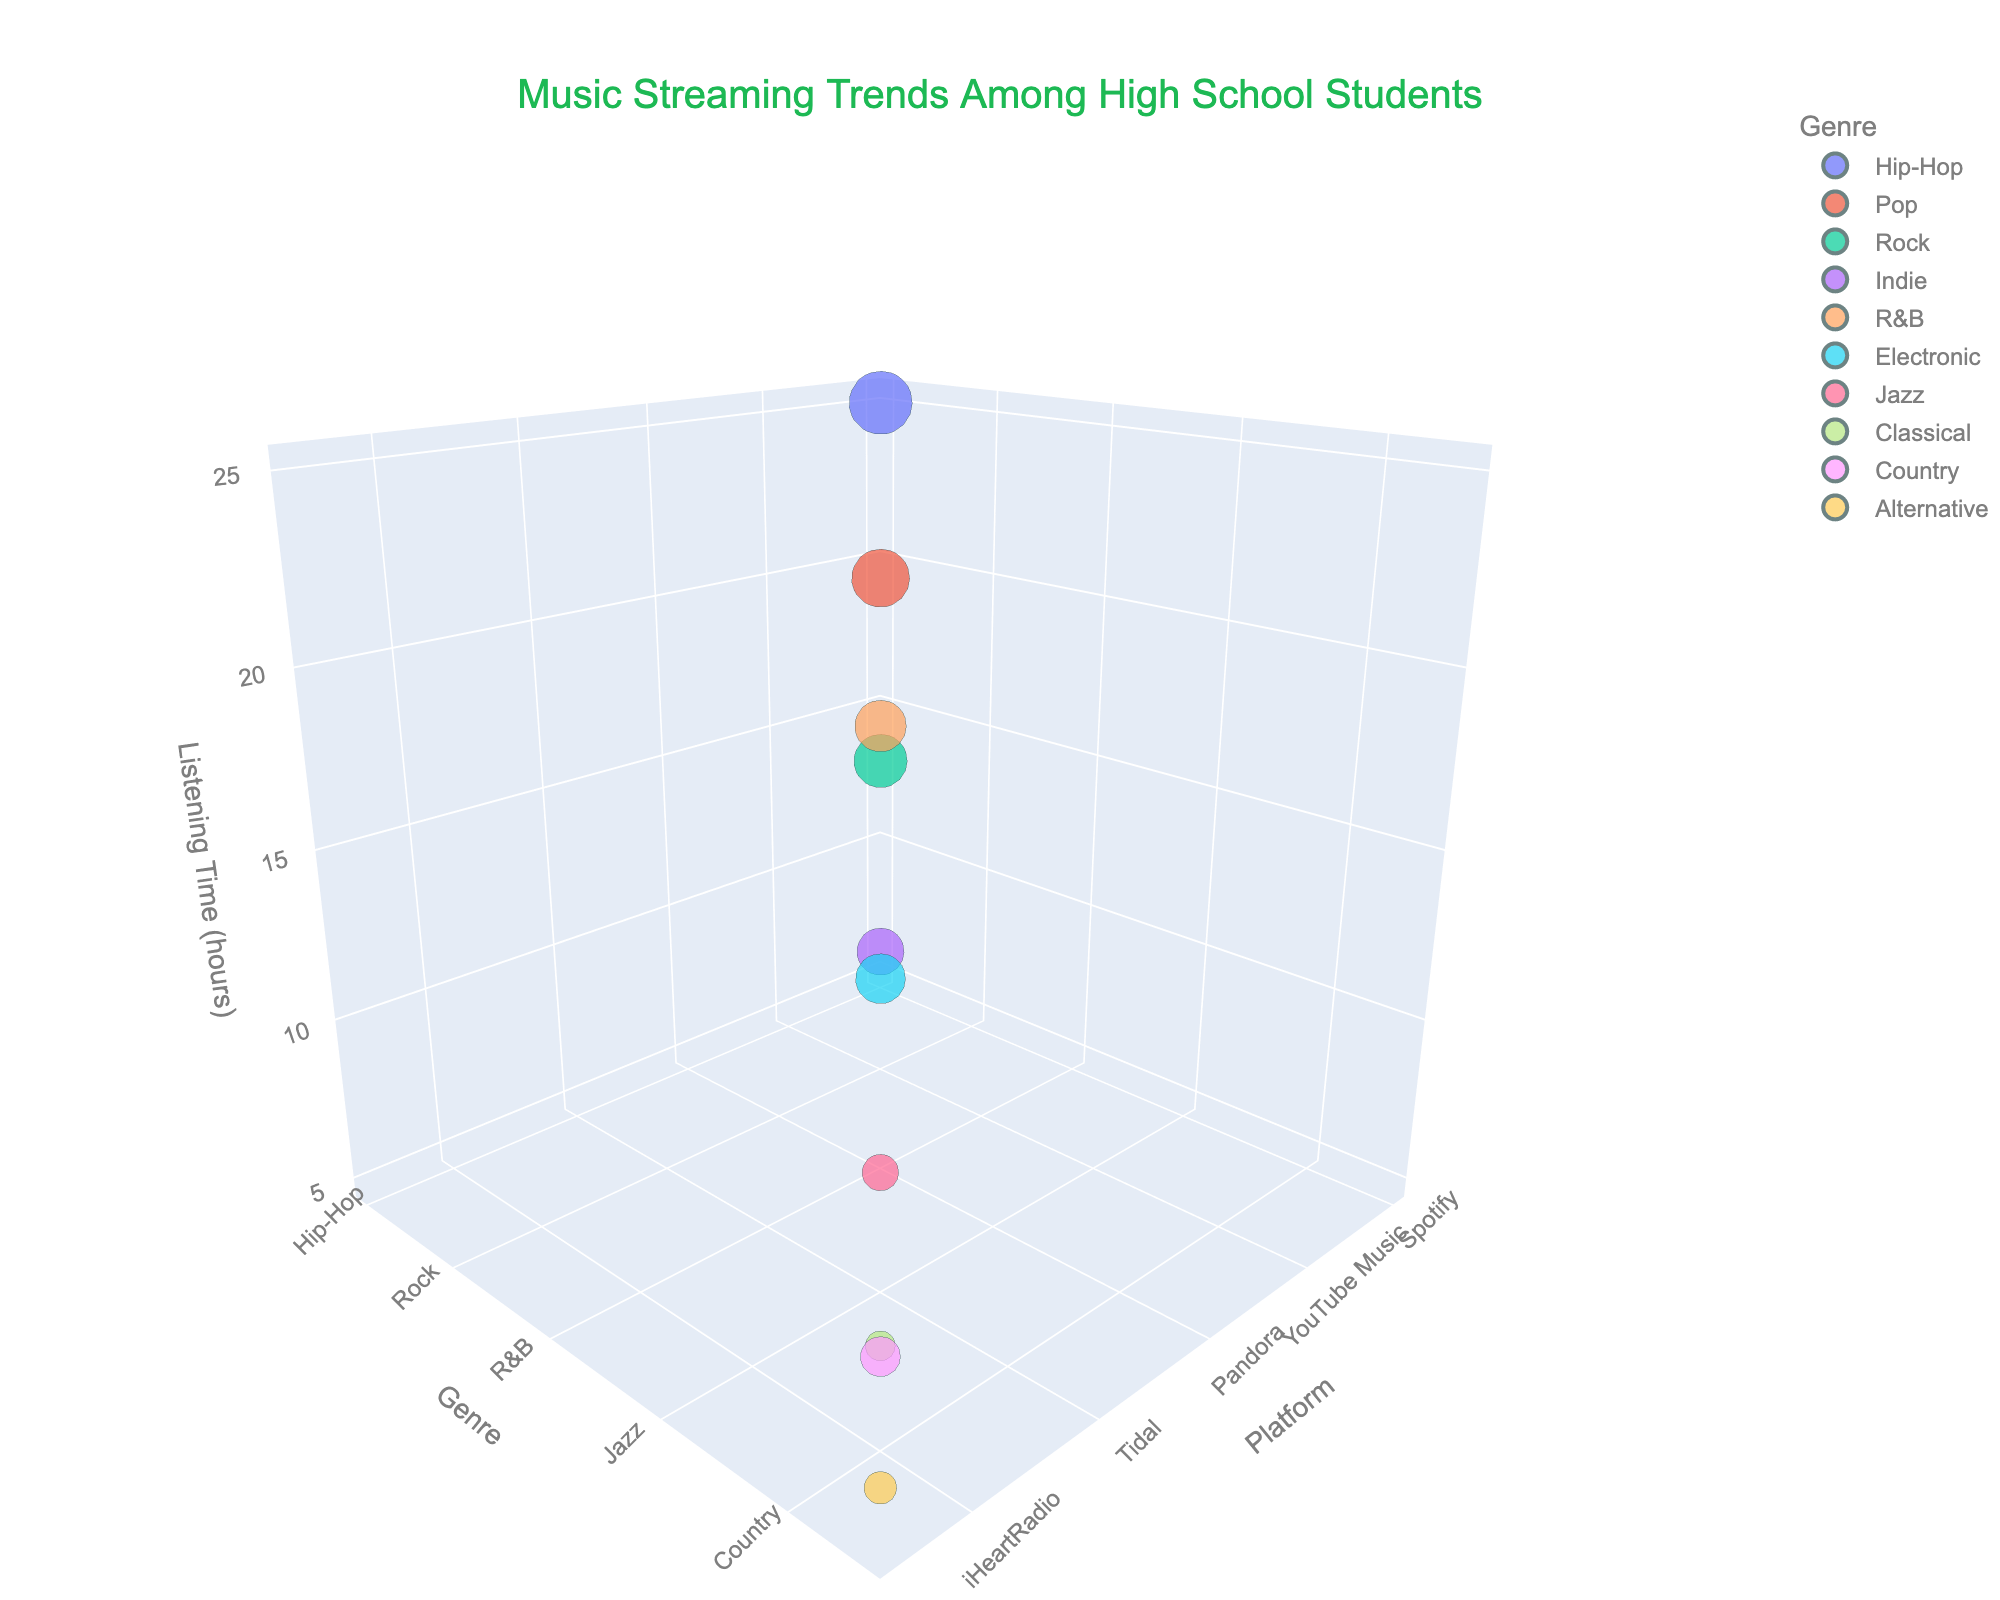What's the title of the 3D bubble chart? The title is usually placed at the top-center of the figure, making it easy to identify.
Answer: Music Streaming Trends Among High School Students Which platform has the highest number of users? The platform with the largest bubble represents the highest number of users, indicated by the size of the bubble.
Answer: Spotify Which genre has the highest listening time? The genre with the highest listening time can be found by looking at the highest point on the Listening Time axis.
Answer: Hip-Hop How many platforms are compared in the chart? Count the number of unique platforms listed along the Platform axis or hover over the bubbles to identify the platforms.
Answer: 10 Which genre appears at the lowest point on the Listening Time axis? Find the genre with the bubble positioned at the lowest point of the Listening Time axis.
Answer: Classical What is the total number of users for Spotify and Apple Music combined? Add the number of users for Spotify (4500) and Apple Music (3800).
Answer: 8300 Which platforms have a listening time less than 10 hours? Identify platforms whose bubbles are positioned below the 10-hour mark on the Listening Time axis.
Answer: Tidal, Deezer, iHeartRadio, Audiomack Compare the listening time for YouTube Music and Amazon Music. Which is higher? Compare the positions of YouTube Music and Amazon Music bubbles along the Listening Time axis.
Answer: YouTube Music What is the average listening time of all platforms together? Add all the listening times and divide by the number of platforms: (25 + 20 + 15 + 10 + 18 + 12 + 8 + 5 + 7 + 6) / 10.
Answer: 12.6 hours Which genre is associated with SoundCloud, and how many users does it have? Look for the bubble corresponding to SoundCloud, and check the associated genre and user count.
Answer: Indie, 2500 